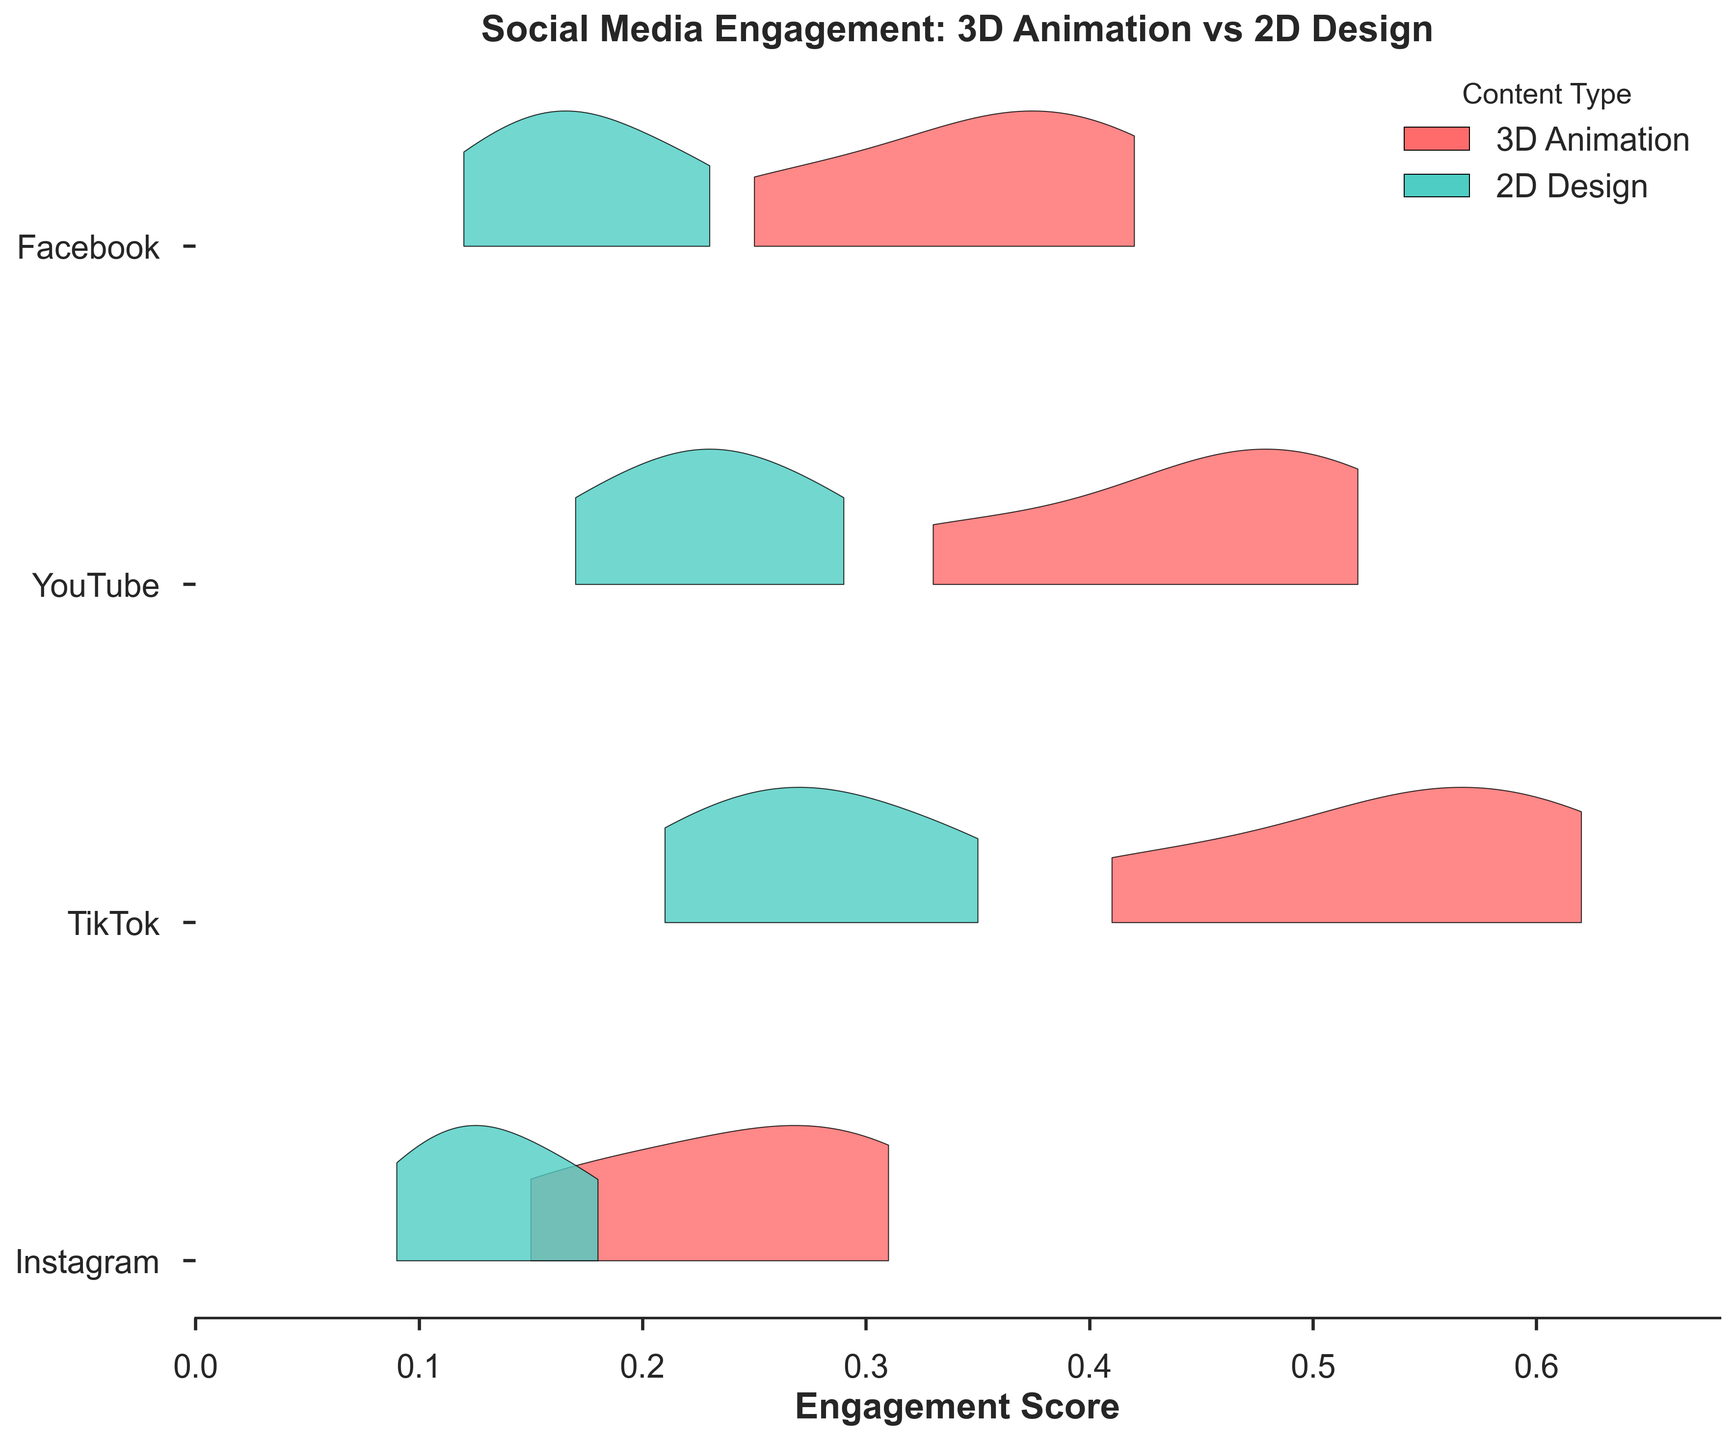What is the title of the figure? The title of the figure is found at the top and it should be succinct. The title usually provides a summary of what the figure is about.
Answer: Social Media Engagement: 3D Animation vs 2D Design What platforms are analyzed in the figure? The platforms are listed along the y-axis in the figure. Each ridgeline corresponds to a different platform.
Answer: Instagram, TikTok, YouTube, Facebook What are the two content types compared in the figure? The content types are indicated by different colors in the figure and the legend on the top right explains what each color represents.
Answer: 3D Animation and 2D Design Which content type consistently shows higher engagement on Instagram? By comparing the ridgelines for 3D Animation and 2D Design on Instagram, we can see which one generally has higher engagement scores.
Answer: 3D Animation How do the engagement scores between the two content types on TikTok differ? To determine the difference in engagement on TikTok, look at the ridgelines for both content types. Note their positions along the Engagement Score axis.
Answer: 3D Animation has higher engagement scores than 2D Design on TikTok Which platform shows the greatest difference in engagement scores between 3D Animation and 2D Design? Compare the separation between ridgelines for 3D Animation and 2D Design across the platforms. The largest gap indicates the greatest difference.
Answer: TikTok What platform shows the least variation in engagement scores for 3D Animation? Observe the width and spread of the ridgeline for 3D Animation in each platform. The platform with the most compact ridgeline shows the least variation.
Answer: Instagram Which content type shows the highest peak engagement score on YouTube? Look at the peaks of the ridgelines for both content types on YouTube. The higher peak indicates the content type with the highest engagement.
Answer: 3D Animation Between Facebook and Instagram, which platform shows a higher peak engagement score for 2D Design? Compare the peak of the ridgelines for 2D Design on Facebook and Instagram. The higher peak indicates the platform with a higher engagement score for 2D Design.
Answer: Facebook Is there a platform where the engagement scores for 2D Design and 3D Animation overlap significantly? Look for platforms where the ridgelines of the two content types are closest to each other, indicating significant overlap.
Answer: No platform shows significant overlap between 2D Design and 3D Animation 